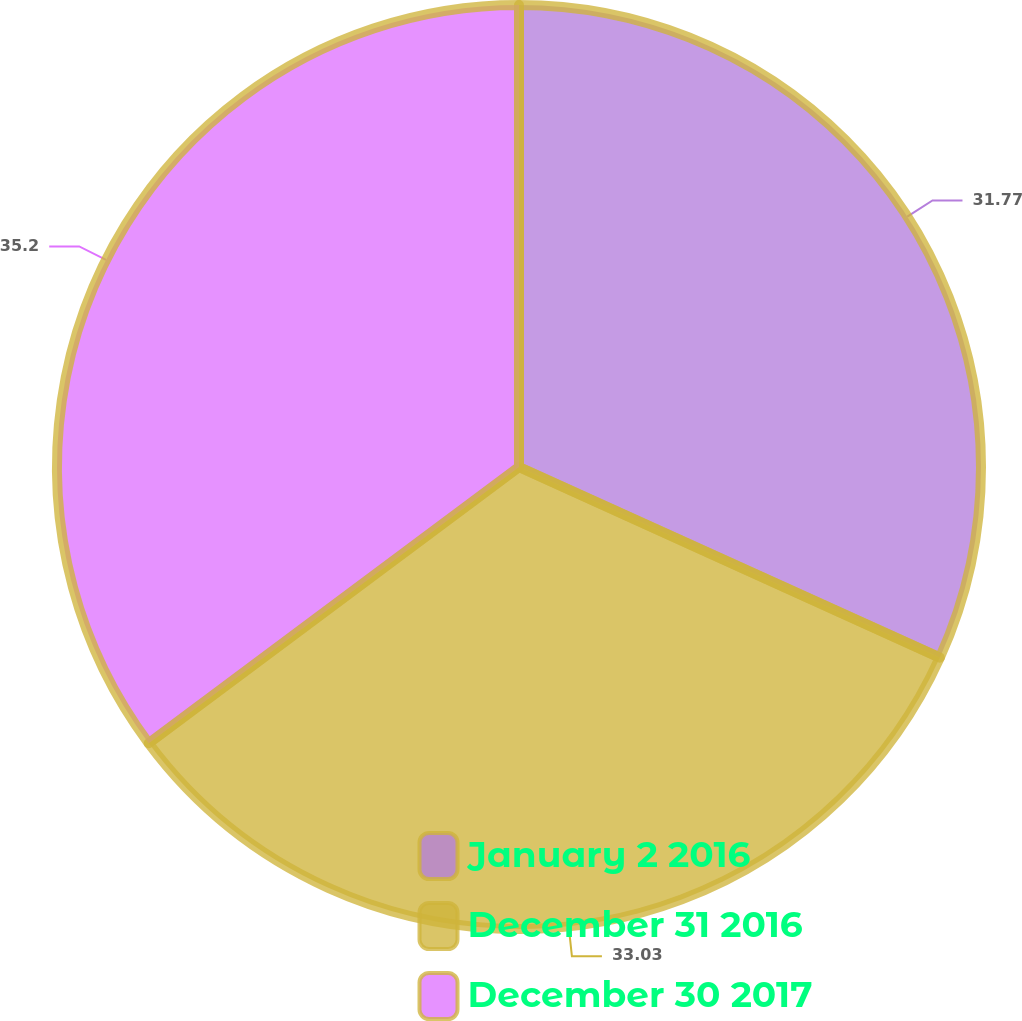Convert chart. <chart><loc_0><loc_0><loc_500><loc_500><pie_chart><fcel>January 2 2016<fcel>December 31 2016<fcel>December 30 2017<nl><fcel>31.77%<fcel>33.03%<fcel>35.2%<nl></chart> 